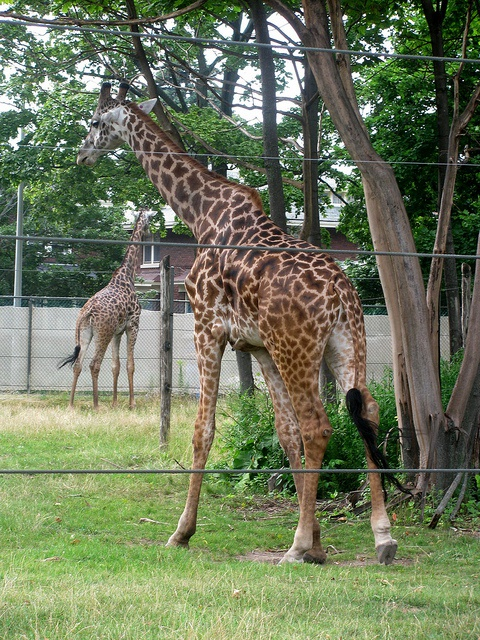Describe the objects in this image and their specific colors. I can see giraffe in lightgreen, gray, and maroon tones and giraffe in lightgreen, gray, and darkgray tones in this image. 